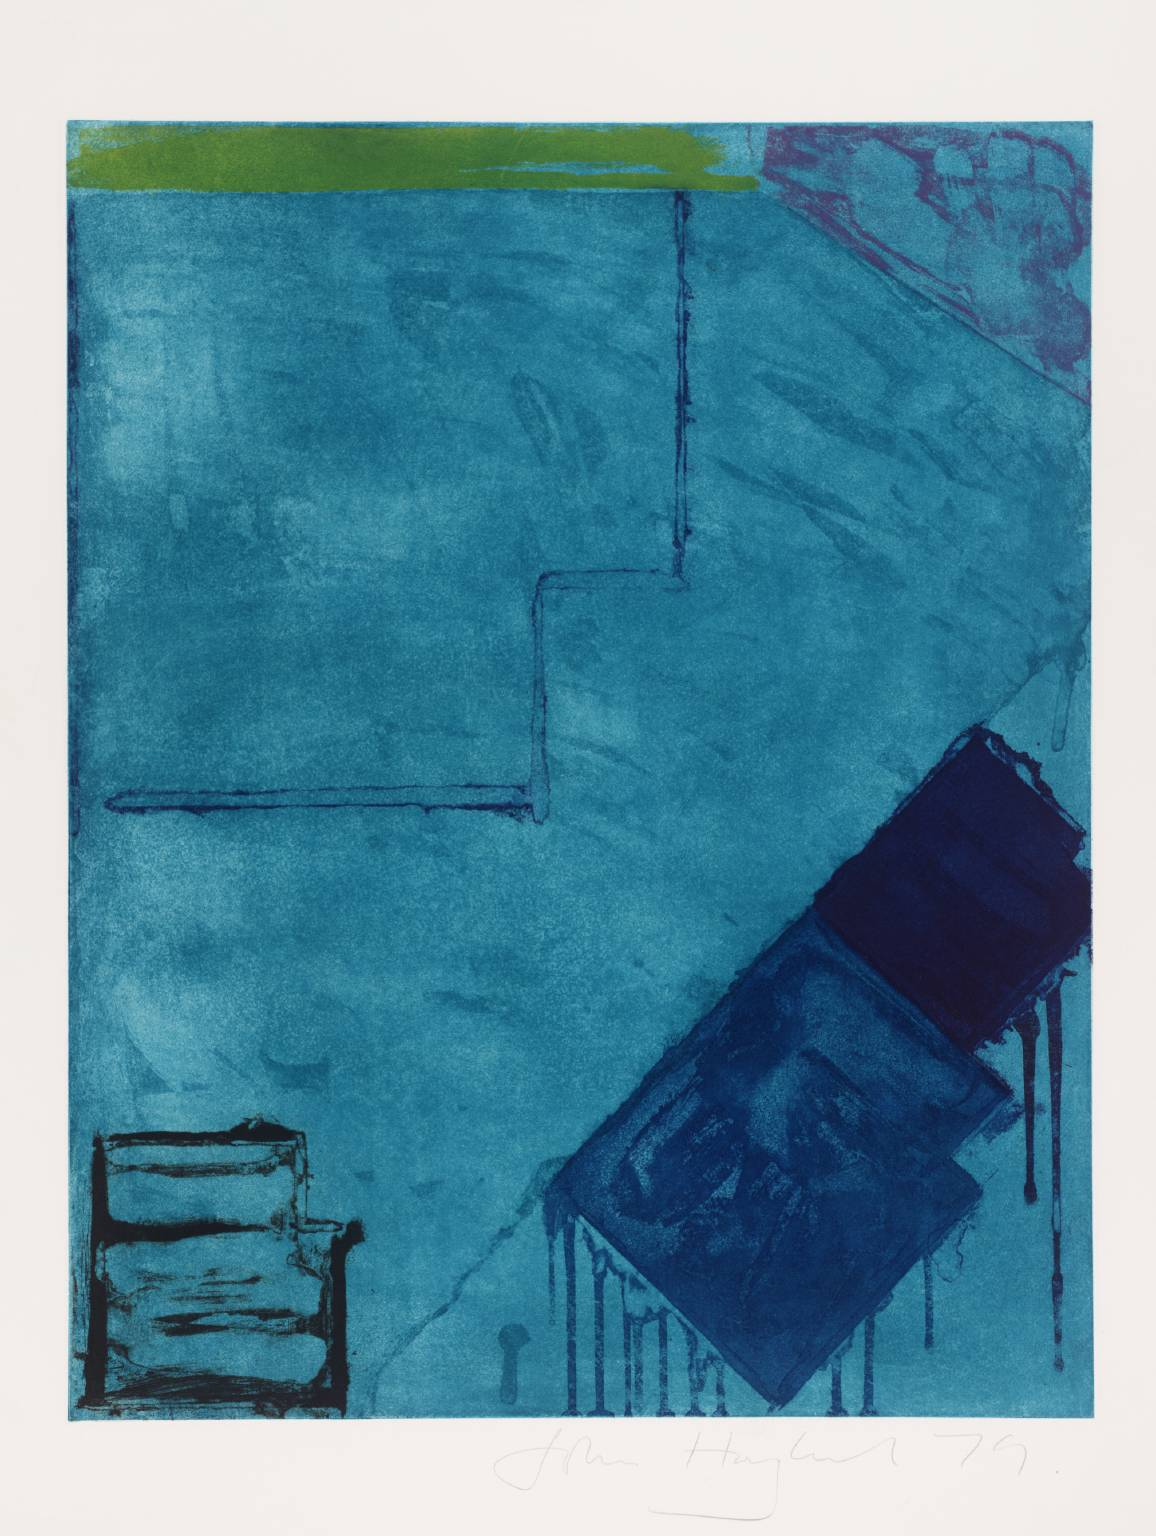What might the artist be trying to communicate with the stark geometric shapes against the abstract background? The interplay of geometric shapes with the abstract background can be seen as a representation of structure within chaos, order juxtaposed with freedom, or the rational mind amidst emotional depth. It provokes a dialogue about balance and the often unseen frameworks that underpin our perceptions of reality. These strong shapes might also direct the viewer's gaze and could symbolize windows or portals, suggesting a passage to different interpretations or states of mind. 